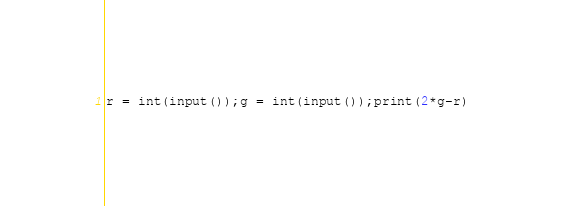Convert code to text. <code><loc_0><loc_0><loc_500><loc_500><_Python_>r = int(input());g = int(input());print(2*g-r)</code> 